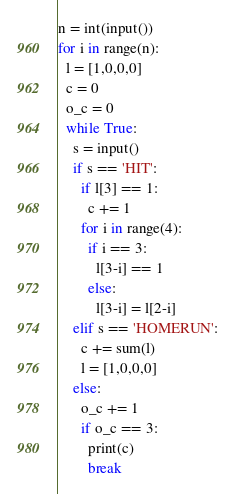<code> <loc_0><loc_0><loc_500><loc_500><_Python_>n = int(input())
for i in range(n):
  l = [1,0,0,0]
  c = 0
  o_c = 0
  while True:
    s = input()
    if s == 'HIT':
      if l[3] == 1:
        c += 1
      for i in range(4):
        if i == 3:
          l[3-i] == 1
        else:
          l[3-i] = l[2-i]
    elif s == 'HOMERUN':
      c += sum(l)
      l = [1,0,0,0]
    else:
      o_c += 1
      if o_c == 3:
        print(c)
        break</code> 